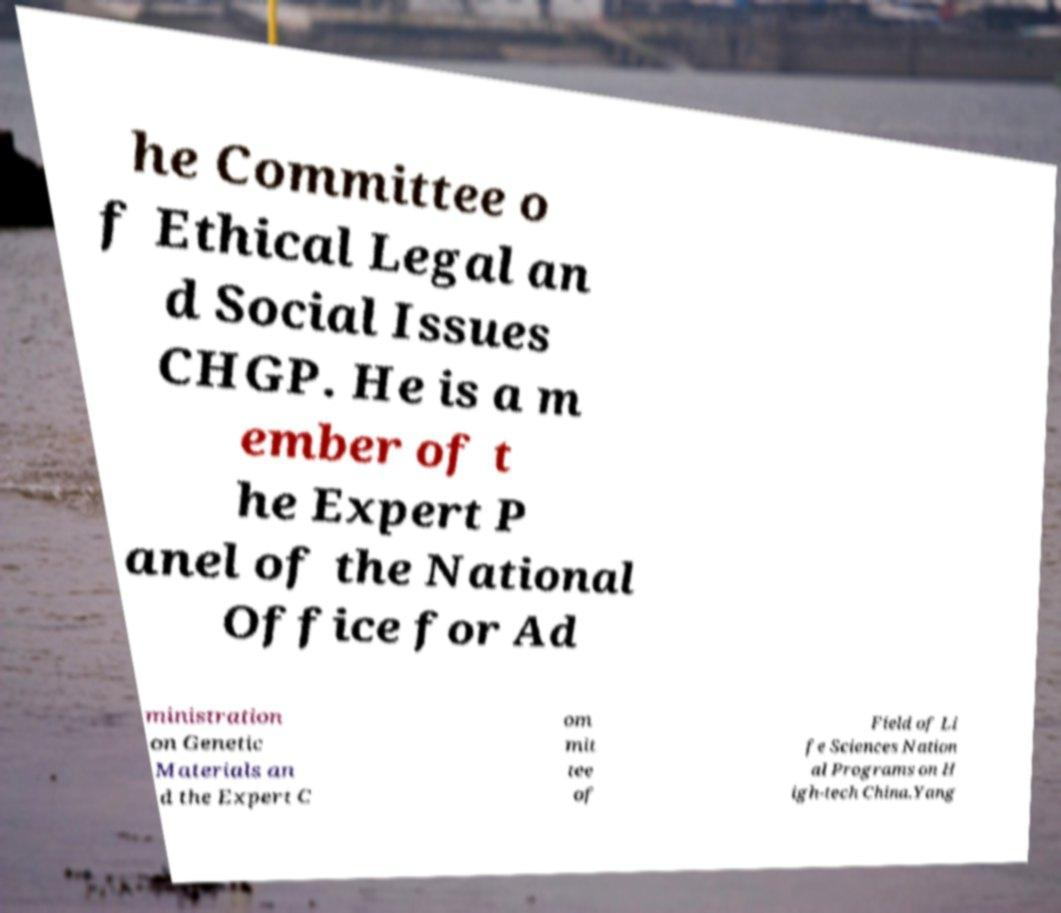For documentation purposes, I need the text within this image transcribed. Could you provide that? he Committee o f Ethical Legal an d Social Issues CHGP. He is a m ember of t he Expert P anel of the National Office for Ad ministration on Genetic Materials an d the Expert C om mit tee of Field of Li fe Sciences Nation al Programs on H igh-tech China.Yang 